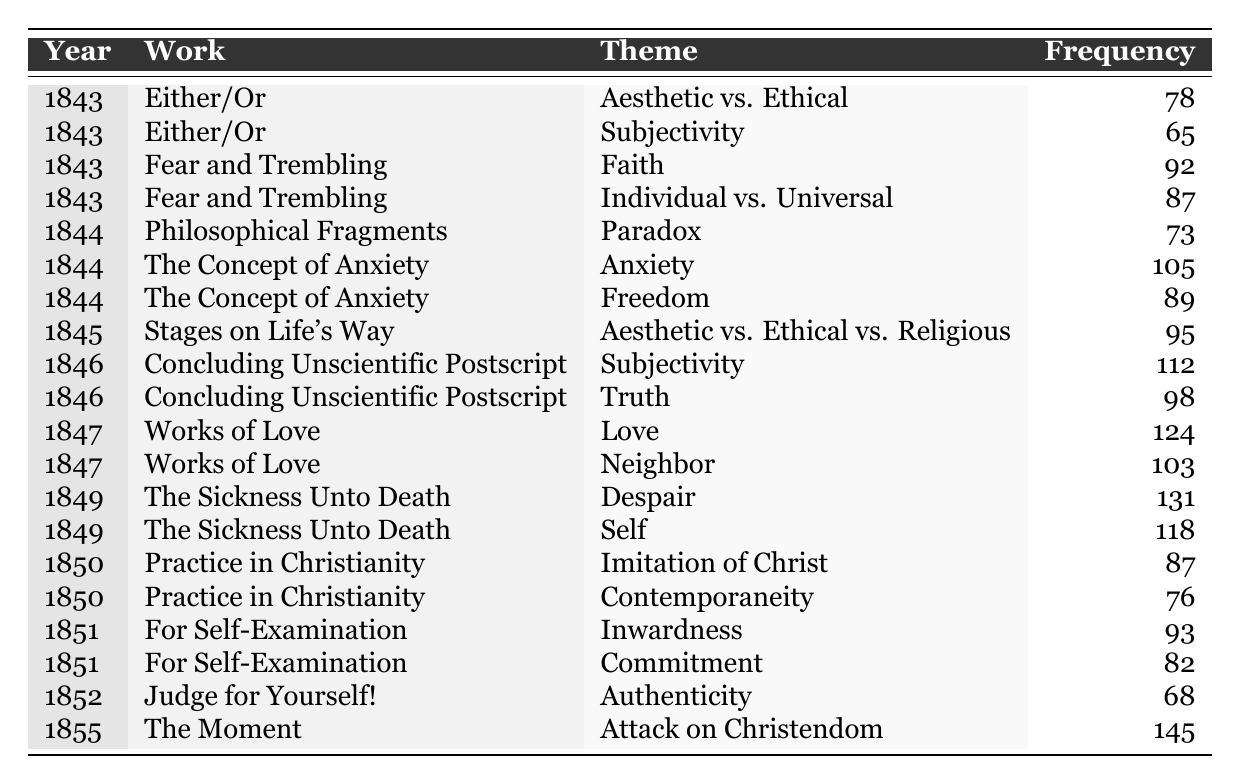What is the theme with the highest frequency in Kierkegaard's writings? The table lists the frequencies of various themes across different works. The theme with the highest frequency is "Attack on Christendom," which has a frequency of 145.
Answer: Attack on Christendom How many times is the theme "Subjectivity" mentioned in "Concluding Unscientific Postscript"? According to the table, the theme "Subjectivity" is mentioned once in "Concluding Unscientific Postscript," with a frequency of 112.
Answer: 112 What theme appears in both "Works of Love" and "The Sickness Unto Death"? The table shows that "Neighbor" appears in "Works of Love" and "Self" appears in "The Sickness Unto Death," indicating that there are no shared themes between the two works.
Answer: None What is the total frequency of the theme "Faith"? The frequency of "Faith" is recorded in "Fear and Trembling" as 92, and there are no additional mentions of this theme elsewhere in the table.
Answer: 92 Was the theme "Despair" addressed more frequently than "Anxiety" in Kierkegaard's writings? "Despair" has a frequency of 131, while "Anxiety" has a frequency of 105, indicating that "Despair" was addressed more frequently than "Anxiety."
Answer: Yes What is the average frequency of the themes in the work "Philosophical Fragments"? The table lists the theme "Paradox" at 73, and there is one entry for "Philosophical Fragments." Hence, the average frequency is simply 73 as there is only one theme.
Answer: 73 Which work contains the highest diversity of existentialist themes in terms of unique themes presented? By analyzing the table, "Works of Love" contains 2 unique themes ("Love" and "Neighbor"), while "The Moment" contains only 1 unique theme. "The Concept of Anxiety" has 2 as well, but no work shows more than 2 themes from this period.
Answer: Works of Love, The Concept of Anxiety (both have 2 unique themes) How does the frequency of "Contemporaneity" compare to that of "Aesthetic vs. Ethical?" "Contemporaneity" has a frequency of 76, while "Aesthetic vs. Ethical" from "Either/Or" is recorded at 78. Comparing these frequencies, "Aesthetic vs. Ethical" is slightly more frequent.
Answer: Aesthetic vs. Ethical is more frequent What is the total frequency of the "Aesthetic vs. Ethical" themes across Kierkegaard's works? The table shows "Aesthetic vs. Ethical" with a frequency of 78 from "Either/Or" and "Aesthetic vs. Ethical vs. Religious" with 95 from "Stages on Life's Way." The total is 78 + 95 = 173.
Answer: 173 What is the theme that appears most frequently in the year 1844? In 1844, the themes listed are "Paradox" (73), "Anxiety" (105), and "Freedom" (89). The highest frequency theme in that year is "Anxiety" with a frequency of 105.
Answer: Anxiety 